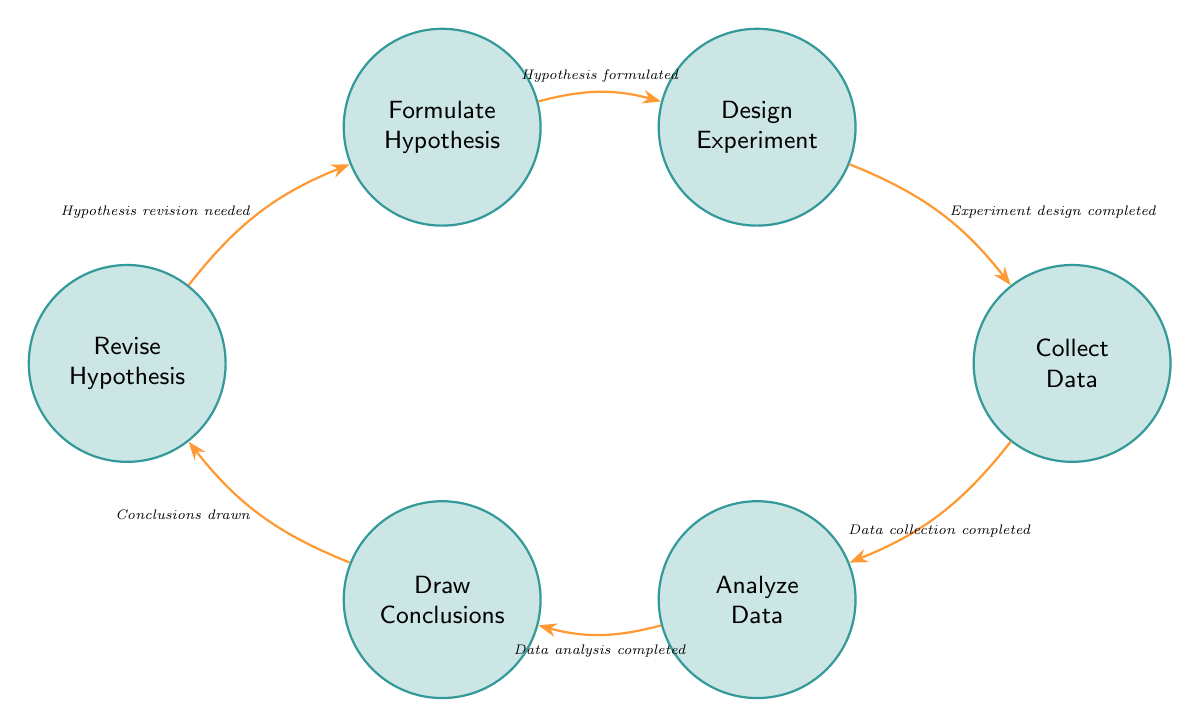What is the first state in the diagram? The first state in the diagram is the one that starts the explanation cycle. It is labeled "Formulate Hypothesis," which is the initial step in this sequence of research activities.
Answer: Formulate Hypothesis How many states are in the Finite State Machine? To find the total number of states, we count each unique state represented in the diagram. The states listed are "Formulate Hypothesis," "Design Experiment," "Collect Data," "Analyze Data," "Draw Conclusions," and "Revise Hypothesis," totaling six.
Answer: 6 What is the transition that follows "Analyze Data"? This transition indicates the next step after "Analyze Data." According to the diagram, the next step is "Draw Conclusions," which occurs following the completion of data analysis.
Answer: Draw Conclusions Which state occurs after "Design Experiment"? This state depends on the established transition rules in the diagram. After "Design Experiment," the next action is to "Collect Data," as indicated by the transition labeled "Experiment design completed."
Answer: Collect Data Which transition is associated with "Revise Hypothesis"? The transition that links to the state "Revise Hypothesis" comes from "Draw Conclusions." This transition is triggered when "Conclusions drawn," indicating that the conclusions dictate a need for hypothesis revision.
Answer: Hypothesis revision needed What is the last state in the cycle? The last state can be identified by tracking the flow from the last transition back to the beginning of the cycle. The last state before returning to "Formulate Hypothesis" is "Revise Hypothesis."
Answer: Revise Hypothesis What is the total number of transitions in the diagram? To determine the total number of transitions, we can count all the labeled arrows in the diagram that indicate movements between states. There are six transitions displayed, connecting each state sequentially in the research cycle.
Answer: 6 Which state must occur after "Collect Data"? The state that occurs immediately after "Collect Data" can be identified by following the transition from that state. The next action is "Analyze Data" once the data collection is complete.
Answer: Analyze Data How many states require a revision after drawing conclusions? Revising a hypothesis is directly associated with drawing conclusions, according to the diagram. Thus, there is only one state that requires revision after completing the conclusions, which is "Revise Hypothesis."
Answer: 1 